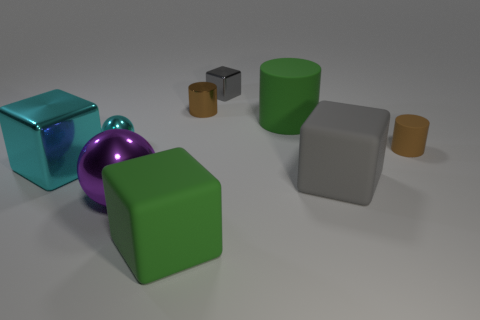What number of small spheres have the same color as the large shiny block?
Ensure brevity in your answer.  1. Is there a tiny shiny object?
Your response must be concise. Yes. There is a green rubber object that is in front of the big cyan metallic thing; what number of metallic cubes are on the right side of it?
Keep it short and to the point. 1. What shape is the big green rubber thing that is in front of the large gray matte block?
Your response must be concise. Cube. The green thing on the right side of the large rubber thing that is on the left side of the big green object that is behind the brown rubber cylinder is made of what material?
Make the answer very short. Rubber. How many other objects are there of the same size as the brown metallic thing?
Keep it short and to the point. 3. What is the material of the large green object that is the same shape as the big gray object?
Your response must be concise. Rubber. What color is the small shiny cube?
Ensure brevity in your answer.  Gray. What is the color of the metal block in front of the tiny cylinder on the left side of the large gray cube?
Make the answer very short. Cyan. Does the big cylinder have the same color as the matte block that is left of the small brown metallic object?
Your response must be concise. Yes. 